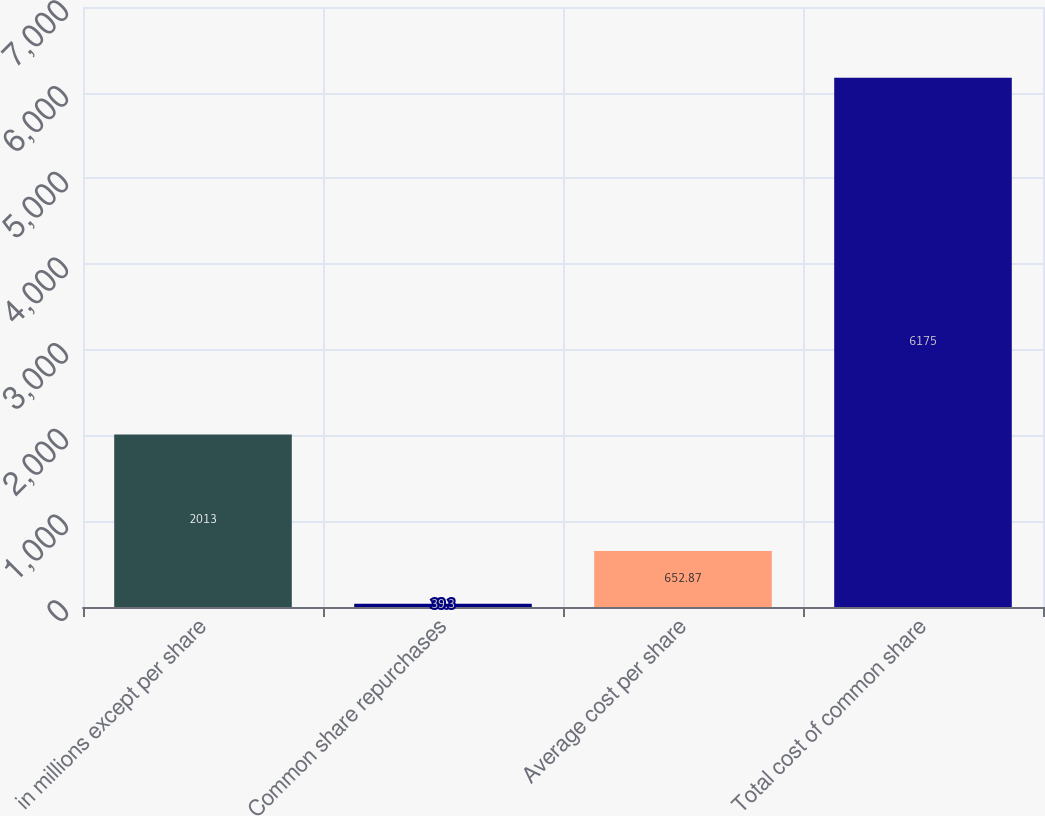Convert chart. <chart><loc_0><loc_0><loc_500><loc_500><bar_chart><fcel>in millions except per share<fcel>Common share repurchases<fcel>Average cost per share<fcel>Total cost of common share<nl><fcel>2013<fcel>39.3<fcel>652.87<fcel>6175<nl></chart> 